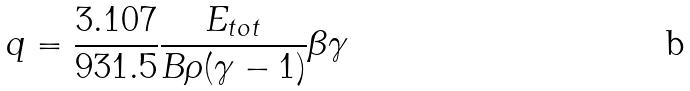Convert formula to latex. <formula><loc_0><loc_0><loc_500><loc_500>q = \frac { 3 . 1 0 7 } { 9 3 1 . 5 } \frac { E _ { t o t } } { B \rho ( \gamma - 1 ) } \beta \gamma</formula> 